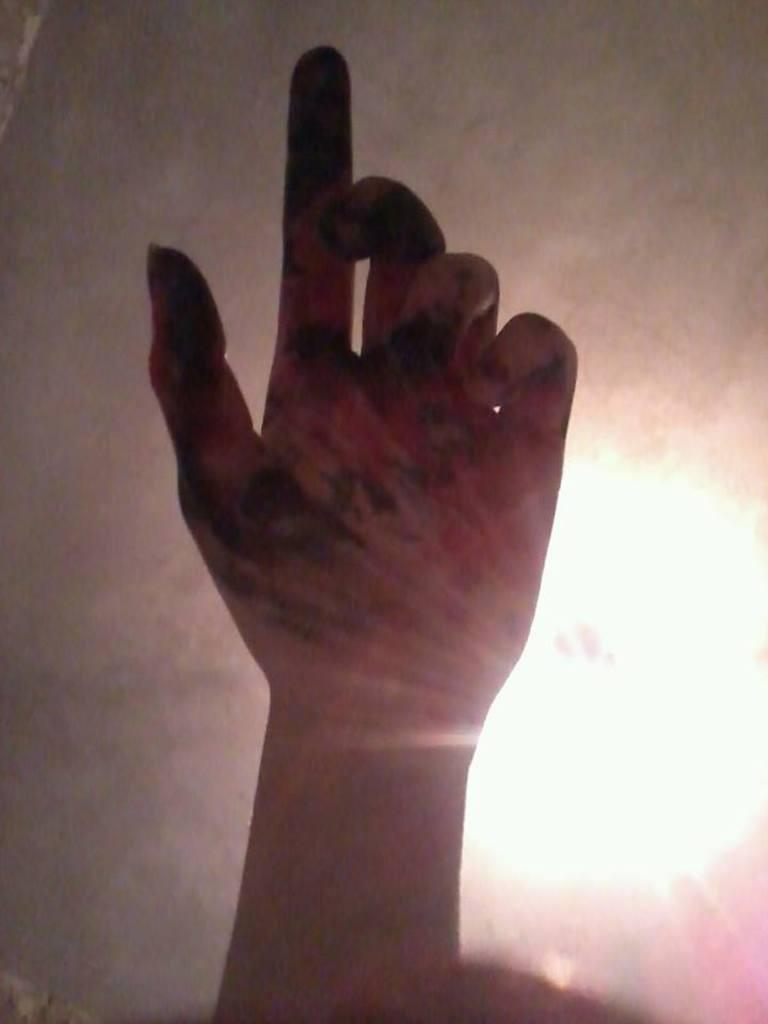What is the main subject of the image? The main subject of the image is a human hand. Can you describe the background of the image? There is light visible in the background of the image, along with a few other objects. What type of bone is being traded in the image? There is no bone or trade activity present in the image; it features a human hand and a background with light and other objects. 